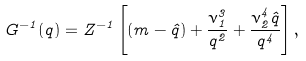Convert formula to latex. <formula><loc_0><loc_0><loc_500><loc_500>G ^ { - 1 } ( q ) = Z ^ { - 1 } \left [ ( m - \hat { q } ) + \frac { \nu _ { 1 } ^ { 3 } } { q ^ { 2 } } + \frac { \nu _ { 2 } ^ { 4 } \hat { q } } { q ^ { 4 } } \right ] ,</formula> 